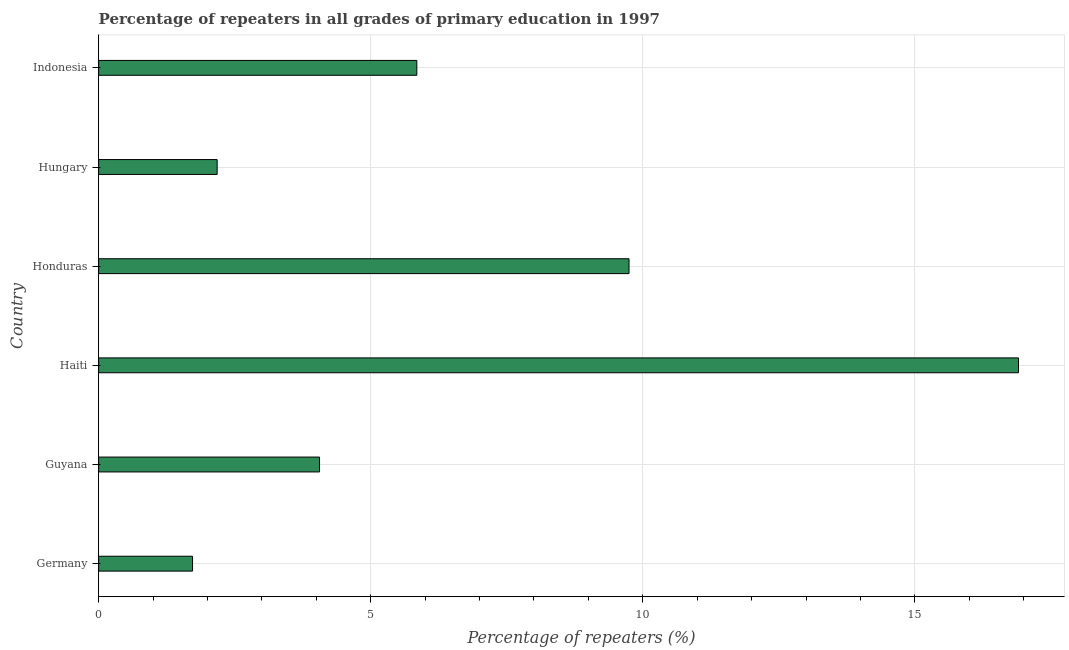Does the graph contain grids?
Make the answer very short. Yes. What is the title of the graph?
Your response must be concise. Percentage of repeaters in all grades of primary education in 1997. What is the label or title of the X-axis?
Offer a very short reply. Percentage of repeaters (%). What is the percentage of repeaters in primary education in Germany?
Provide a succinct answer. 1.73. Across all countries, what is the maximum percentage of repeaters in primary education?
Your answer should be very brief. 16.91. Across all countries, what is the minimum percentage of repeaters in primary education?
Offer a terse response. 1.73. In which country was the percentage of repeaters in primary education maximum?
Provide a succinct answer. Haiti. What is the sum of the percentage of repeaters in primary education?
Keep it short and to the point. 40.46. What is the difference between the percentage of repeaters in primary education in Hungary and Indonesia?
Give a very brief answer. -3.67. What is the average percentage of repeaters in primary education per country?
Your answer should be compact. 6.74. What is the median percentage of repeaters in primary education?
Offer a very short reply. 4.95. What is the ratio of the percentage of repeaters in primary education in Guyana to that in Indonesia?
Offer a terse response. 0.69. Is the difference between the percentage of repeaters in primary education in Hungary and Indonesia greater than the difference between any two countries?
Make the answer very short. No. What is the difference between the highest and the second highest percentage of repeaters in primary education?
Your answer should be compact. 7.16. Is the sum of the percentage of repeaters in primary education in Germany and Honduras greater than the maximum percentage of repeaters in primary education across all countries?
Provide a short and direct response. No. What is the difference between the highest and the lowest percentage of repeaters in primary education?
Your answer should be compact. 15.18. In how many countries, is the percentage of repeaters in primary education greater than the average percentage of repeaters in primary education taken over all countries?
Provide a short and direct response. 2. How many bars are there?
Offer a terse response. 6. What is the difference between two consecutive major ticks on the X-axis?
Ensure brevity in your answer.  5. What is the Percentage of repeaters (%) in Germany?
Offer a very short reply. 1.73. What is the Percentage of repeaters (%) of Guyana?
Offer a terse response. 4.06. What is the Percentage of repeaters (%) of Haiti?
Ensure brevity in your answer.  16.91. What is the Percentage of repeaters (%) of Honduras?
Make the answer very short. 9.75. What is the Percentage of repeaters (%) of Hungary?
Make the answer very short. 2.18. What is the Percentage of repeaters (%) in Indonesia?
Offer a very short reply. 5.85. What is the difference between the Percentage of repeaters (%) in Germany and Guyana?
Give a very brief answer. -2.33. What is the difference between the Percentage of repeaters (%) in Germany and Haiti?
Provide a succinct answer. -15.18. What is the difference between the Percentage of repeaters (%) in Germany and Honduras?
Make the answer very short. -8.02. What is the difference between the Percentage of repeaters (%) in Germany and Hungary?
Offer a terse response. -0.45. What is the difference between the Percentage of repeaters (%) in Germany and Indonesia?
Give a very brief answer. -4.12. What is the difference between the Percentage of repeaters (%) in Guyana and Haiti?
Your answer should be compact. -12.85. What is the difference between the Percentage of repeaters (%) in Guyana and Honduras?
Offer a very short reply. -5.69. What is the difference between the Percentage of repeaters (%) in Guyana and Hungary?
Ensure brevity in your answer.  1.88. What is the difference between the Percentage of repeaters (%) in Guyana and Indonesia?
Your response must be concise. -1.79. What is the difference between the Percentage of repeaters (%) in Haiti and Honduras?
Your answer should be compact. 7.16. What is the difference between the Percentage of repeaters (%) in Haiti and Hungary?
Make the answer very short. 14.73. What is the difference between the Percentage of repeaters (%) in Haiti and Indonesia?
Your response must be concise. 11.06. What is the difference between the Percentage of repeaters (%) in Honduras and Hungary?
Offer a terse response. 7.57. What is the difference between the Percentage of repeaters (%) in Honduras and Indonesia?
Provide a succinct answer. 3.9. What is the difference between the Percentage of repeaters (%) in Hungary and Indonesia?
Make the answer very short. -3.67. What is the ratio of the Percentage of repeaters (%) in Germany to that in Guyana?
Your answer should be compact. 0.42. What is the ratio of the Percentage of repeaters (%) in Germany to that in Haiti?
Make the answer very short. 0.1. What is the ratio of the Percentage of repeaters (%) in Germany to that in Honduras?
Offer a very short reply. 0.18. What is the ratio of the Percentage of repeaters (%) in Germany to that in Hungary?
Offer a very short reply. 0.79. What is the ratio of the Percentage of repeaters (%) in Germany to that in Indonesia?
Your answer should be very brief. 0.29. What is the ratio of the Percentage of repeaters (%) in Guyana to that in Haiti?
Your answer should be very brief. 0.24. What is the ratio of the Percentage of repeaters (%) in Guyana to that in Honduras?
Offer a very short reply. 0.42. What is the ratio of the Percentage of repeaters (%) in Guyana to that in Hungary?
Provide a succinct answer. 1.86. What is the ratio of the Percentage of repeaters (%) in Guyana to that in Indonesia?
Make the answer very short. 0.69. What is the ratio of the Percentage of repeaters (%) in Haiti to that in Honduras?
Your answer should be very brief. 1.73. What is the ratio of the Percentage of repeaters (%) in Haiti to that in Hungary?
Your response must be concise. 7.76. What is the ratio of the Percentage of repeaters (%) in Haiti to that in Indonesia?
Make the answer very short. 2.89. What is the ratio of the Percentage of repeaters (%) in Honduras to that in Hungary?
Provide a short and direct response. 4.47. What is the ratio of the Percentage of repeaters (%) in Honduras to that in Indonesia?
Your answer should be compact. 1.67. What is the ratio of the Percentage of repeaters (%) in Hungary to that in Indonesia?
Your answer should be very brief. 0.37. 